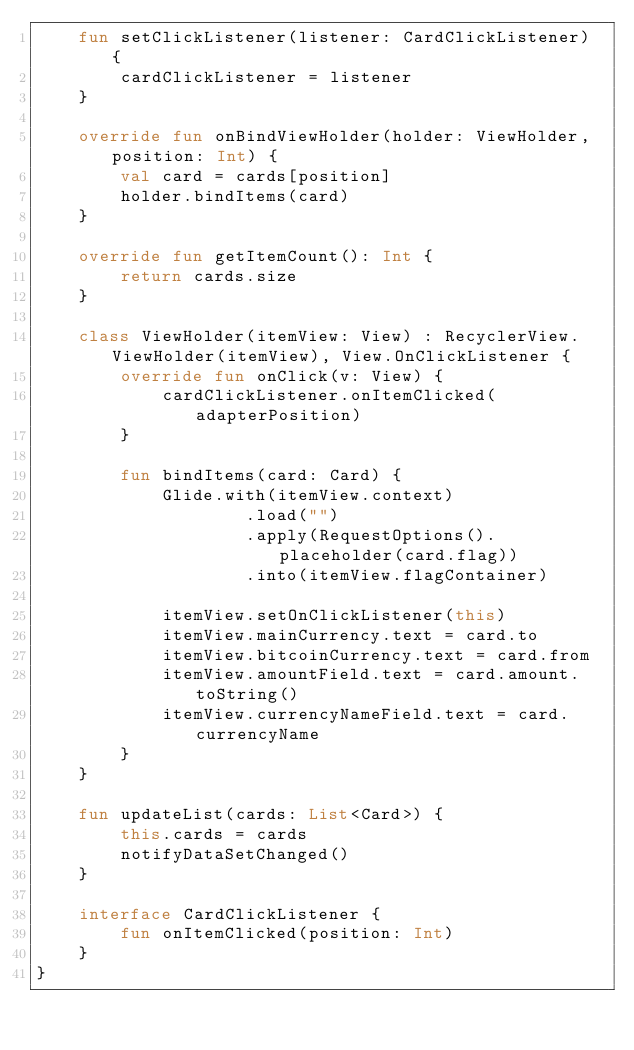Convert code to text. <code><loc_0><loc_0><loc_500><loc_500><_Kotlin_>    fun setClickListener(listener: CardClickListener) {
        cardClickListener = listener
    }

    override fun onBindViewHolder(holder: ViewHolder, position: Int) {
        val card = cards[position]
        holder.bindItems(card)
    }

    override fun getItemCount(): Int {
        return cards.size
    }

    class ViewHolder(itemView: View) : RecyclerView.ViewHolder(itemView), View.OnClickListener {
        override fun onClick(v: View) {
            cardClickListener.onItemClicked(adapterPosition)
        }

        fun bindItems(card: Card) {
            Glide.with(itemView.context)
                    .load("")
                    .apply(RequestOptions().placeholder(card.flag))
                    .into(itemView.flagContainer)

            itemView.setOnClickListener(this)
            itemView.mainCurrency.text = card.to
            itemView.bitcoinCurrency.text = card.from
            itemView.amountField.text = card.amount.toString()
            itemView.currencyNameField.text = card.currencyName
        }
    }

    fun updateList(cards: List<Card>) {
        this.cards = cards
        notifyDataSetChanged()
    }

    interface CardClickListener {
        fun onItemClicked(position: Int)
    }
}</code> 